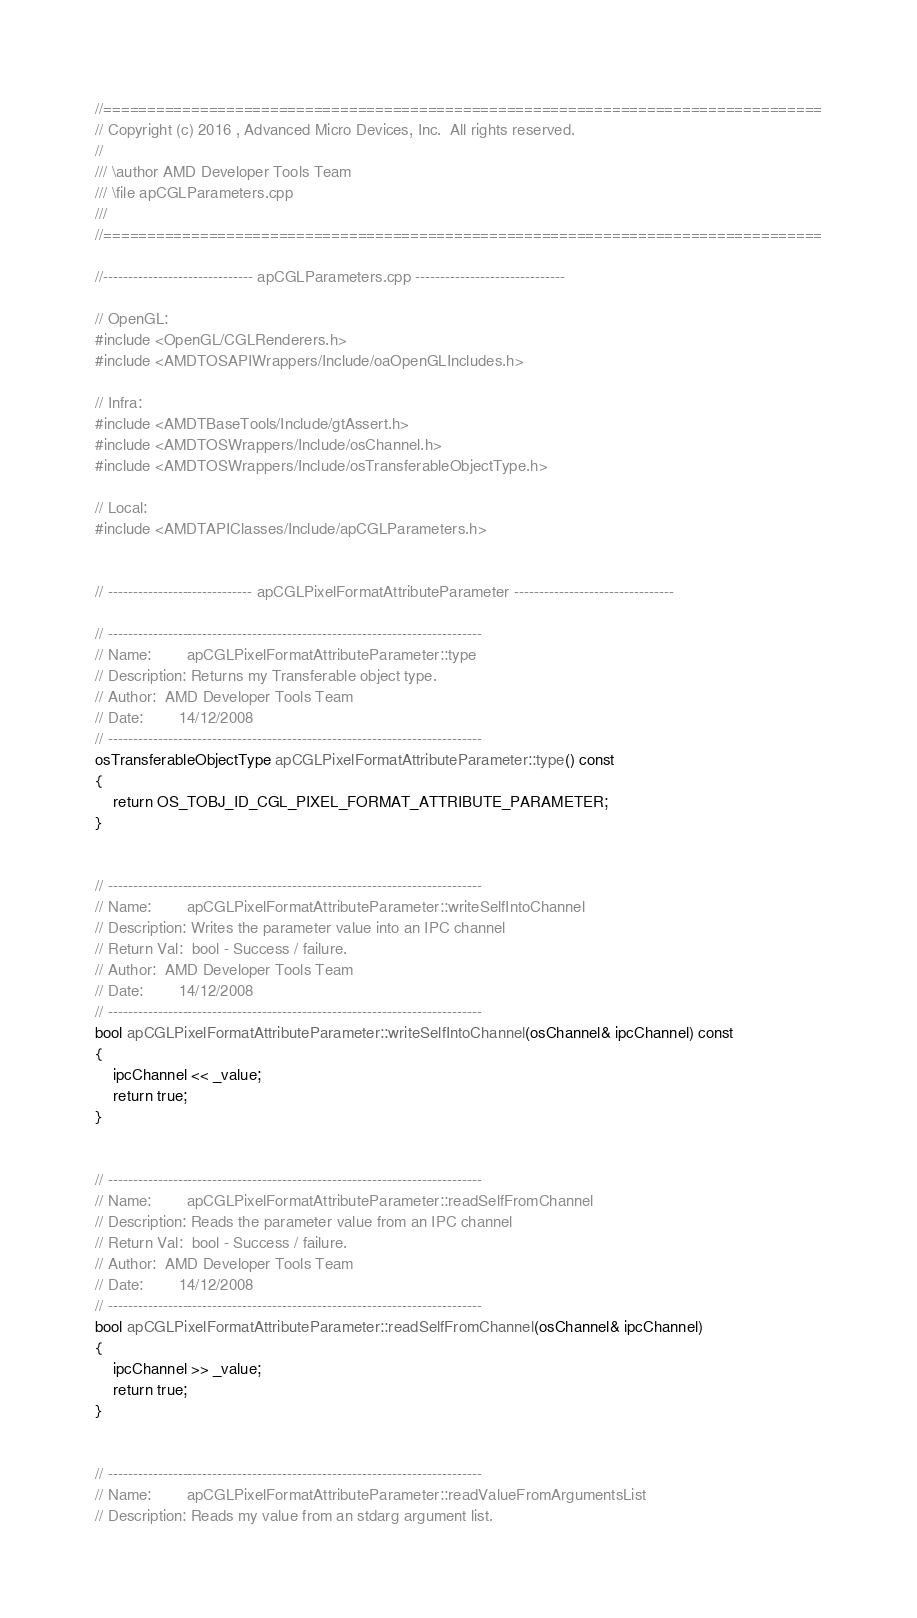Convert code to text. <code><loc_0><loc_0><loc_500><loc_500><_C++_>//==================================================================================
// Copyright (c) 2016 , Advanced Micro Devices, Inc.  All rights reserved.
//
/// \author AMD Developer Tools Team
/// \file apCGLParameters.cpp
///
//==================================================================================

//------------------------------ apCGLParameters.cpp ------------------------------

// OpenGL:
#include <OpenGL/CGLRenderers.h>
#include <AMDTOSAPIWrappers/Include/oaOpenGLIncludes.h>

// Infra:
#include <AMDTBaseTools/Include/gtAssert.h>
#include <AMDTOSWrappers/Include/osChannel.h>
#include <AMDTOSWrappers/Include/osTransferableObjectType.h>

// Local:
#include <AMDTAPIClasses/Include/apCGLParameters.h>


// ----------------------------- apCGLPixelFormatAttributeParameter --------------------------------

// ---------------------------------------------------------------------------
// Name:        apCGLPixelFormatAttributeParameter::type
// Description: Returns my Transferable object type.
// Author:  AMD Developer Tools Team
// Date:        14/12/2008
// ---------------------------------------------------------------------------
osTransferableObjectType apCGLPixelFormatAttributeParameter::type() const
{
    return OS_TOBJ_ID_CGL_PIXEL_FORMAT_ATTRIBUTE_PARAMETER;
}


// ---------------------------------------------------------------------------
// Name:        apCGLPixelFormatAttributeParameter::writeSelfIntoChannel
// Description: Writes the parameter value into an IPC channel
// Return Val:  bool - Success / failure.
// Author:  AMD Developer Tools Team
// Date:        14/12/2008
// ---------------------------------------------------------------------------
bool apCGLPixelFormatAttributeParameter::writeSelfIntoChannel(osChannel& ipcChannel) const
{
    ipcChannel << _value;
    return true;
}


// ---------------------------------------------------------------------------
// Name:        apCGLPixelFormatAttributeParameter::readSelfFromChannel
// Description: Reads the parameter value from an IPC channel
// Return Val:  bool - Success / failure.
// Author:  AMD Developer Tools Team
// Date:        14/12/2008
// ---------------------------------------------------------------------------
bool apCGLPixelFormatAttributeParameter::readSelfFromChannel(osChannel& ipcChannel)
{
    ipcChannel >> _value;
    return true;
}


// ---------------------------------------------------------------------------
// Name:        apCGLPixelFormatAttributeParameter::readValueFromArgumentsList
// Description: Reads my value from an stdarg argument list.</code> 